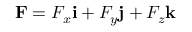<formula> <loc_0><loc_0><loc_500><loc_500>F = F _ { x } i + F _ { y } j + F _ { z } k</formula> 